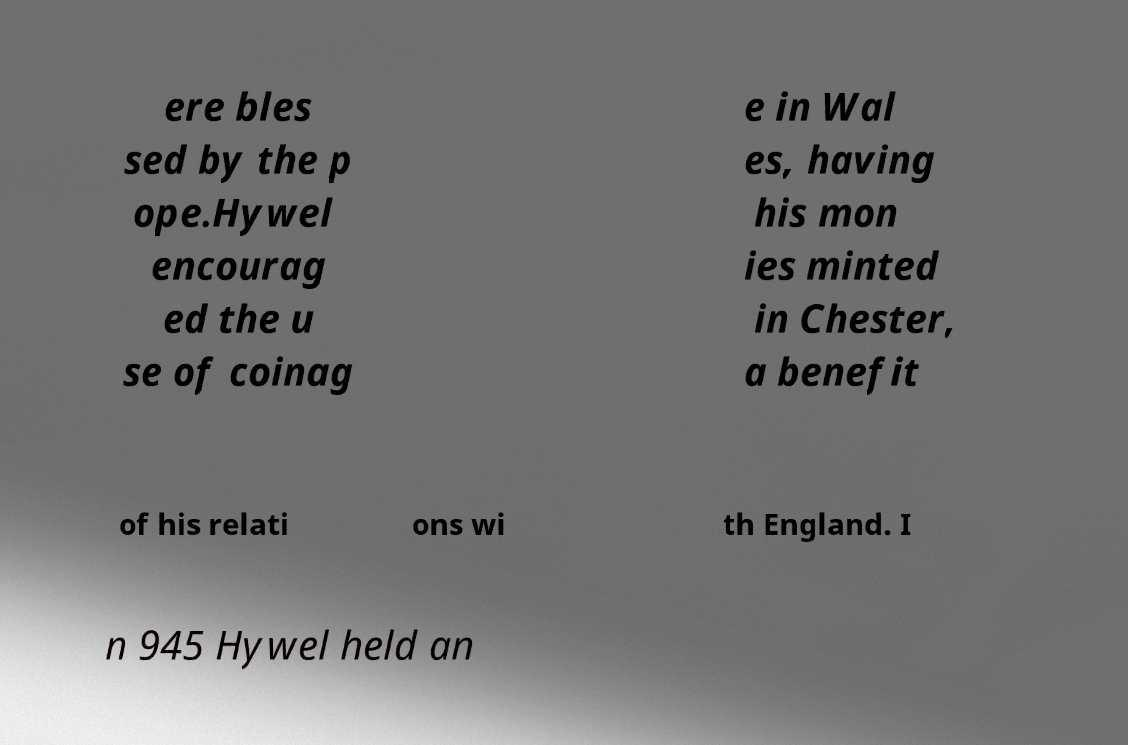Please read and relay the text visible in this image. What does it say? ere bles sed by the p ope.Hywel encourag ed the u se of coinag e in Wal es, having his mon ies minted in Chester, a benefit of his relati ons wi th England. I n 945 Hywel held an 